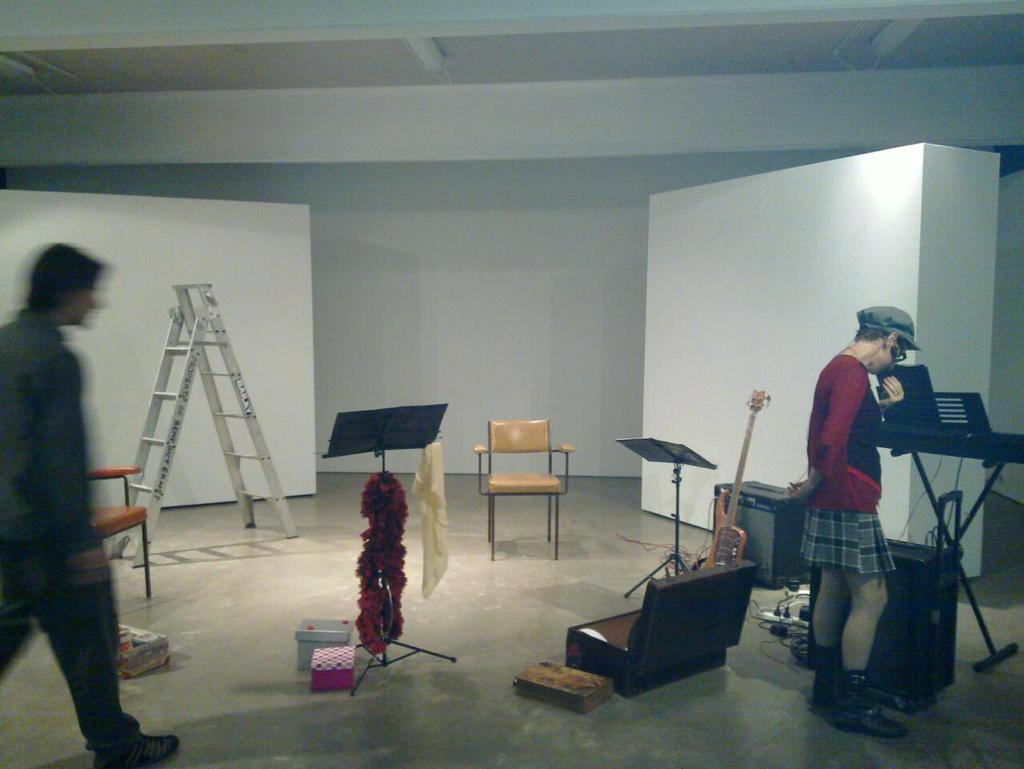In one or two sentences, can you explain what this image depicts? The image is taken in the room. In the center of the image there is a chair. There is a stand. At the bottom there is a briefcase. On the right there is a man standing. There are speakers. In the background there is a ladder, a board and a wall. On the right there is a man walking. 